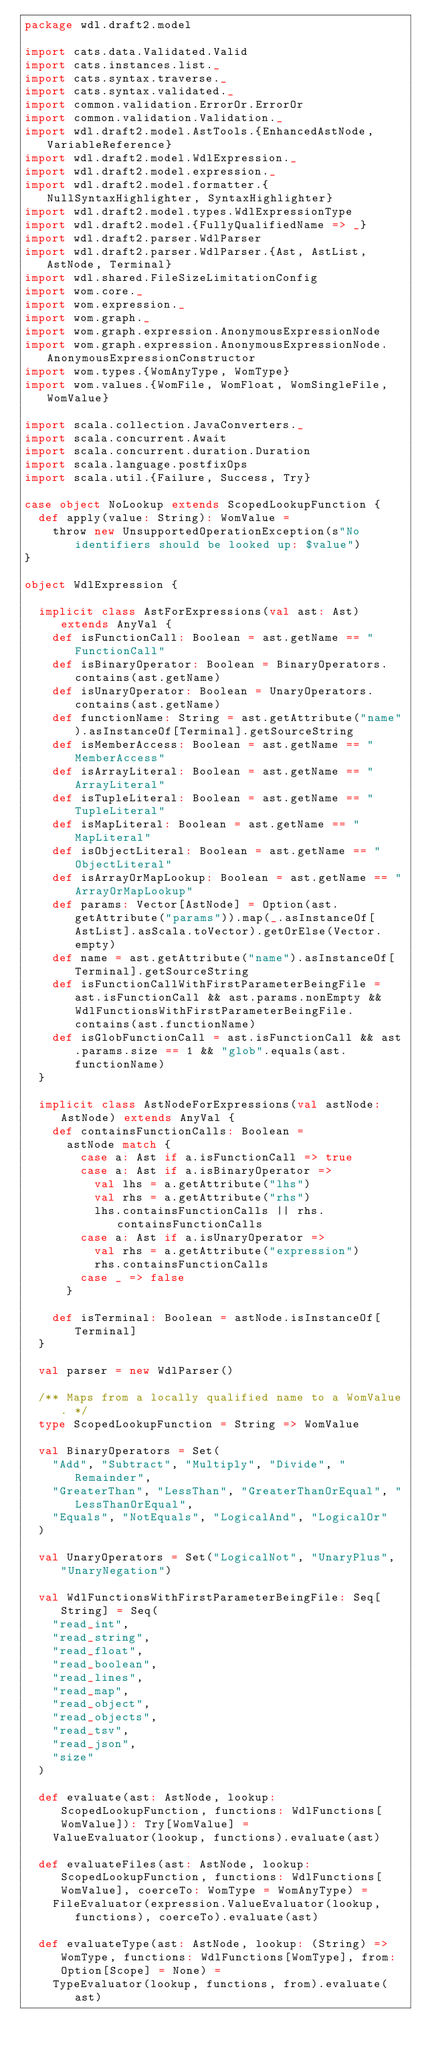<code> <loc_0><loc_0><loc_500><loc_500><_Scala_>package wdl.draft2.model

import cats.data.Validated.Valid
import cats.instances.list._
import cats.syntax.traverse._
import cats.syntax.validated._
import common.validation.ErrorOr.ErrorOr
import common.validation.Validation._
import wdl.draft2.model.AstTools.{EnhancedAstNode, VariableReference}
import wdl.draft2.model.WdlExpression._
import wdl.draft2.model.expression._
import wdl.draft2.model.formatter.{NullSyntaxHighlighter, SyntaxHighlighter}
import wdl.draft2.model.types.WdlExpressionType
import wdl.draft2.model.{FullyQualifiedName => _}
import wdl.draft2.parser.WdlParser
import wdl.draft2.parser.WdlParser.{Ast, AstList, AstNode, Terminal}
import wdl.shared.FileSizeLimitationConfig
import wom.core._
import wom.expression._
import wom.graph._
import wom.graph.expression.AnonymousExpressionNode
import wom.graph.expression.AnonymousExpressionNode.AnonymousExpressionConstructor
import wom.types.{WomAnyType, WomType}
import wom.values.{WomFile, WomFloat, WomSingleFile, WomValue}

import scala.collection.JavaConverters._
import scala.concurrent.Await
import scala.concurrent.duration.Duration
import scala.language.postfixOps
import scala.util.{Failure, Success, Try}

case object NoLookup extends ScopedLookupFunction {
  def apply(value: String): WomValue =
    throw new UnsupportedOperationException(s"No identifiers should be looked up: $value")
}

object WdlExpression {

  implicit class AstForExpressions(val ast: Ast) extends AnyVal {
    def isFunctionCall: Boolean = ast.getName == "FunctionCall"
    def isBinaryOperator: Boolean = BinaryOperators.contains(ast.getName)
    def isUnaryOperator: Boolean = UnaryOperators.contains(ast.getName)
    def functionName: String = ast.getAttribute("name").asInstanceOf[Terminal].getSourceString
    def isMemberAccess: Boolean = ast.getName == "MemberAccess"
    def isArrayLiteral: Boolean = ast.getName == "ArrayLiteral"
    def isTupleLiteral: Boolean = ast.getName == "TupleLiteral"
    def isMapLiteral: Boolean = ast.getName == "MapLiteral"
    def isObjectLiteral: Boolean = ast.getName == "ObjectLiteral"
    def isArrayOrMapLookup: Boolean = ast.getName == "ArrayOrMapLookup"
    def params: Vector[AstNode] = Option(ast.getAttribute("params")).map(_.asInstanceOf[AstList].asScala.toVector).getOrElse(Vector.empty)
    def name = ast.getAttribute("name").asInstanceOf[Terminal].getSourceString
    def isFunctionCallWithFirstParameterBeingFile = ast.isFunctionCall && ast.params.nonEmpty && WdlFunctionsWithFirstParameterBeingFile.contains(ast.functionName)
    def isGlobFunctionCall = ast.isFunctionCall && ast.params.size == 1 && "glob".equals(ast.functionName)
  }

  implicit class AstNodeForExpressions(val astNode: AstNode) extends AnyVal {
    def containsFunctionCalls: Boolean =
      astNode match {
        case a: Ast if a.isFunctionCall => true
        case a: Ast if a.isBinaryOperator =>
          val lhs = a.getAttribute("lhs")
          val rhs = a.getAttribute("rhs")
          lhs.containsFunctionCalls || rhs.containsFunctionCalls
        case a: Ast if a.isUnaryOperator =>
          val rhs = a.getAttribute("expression")
          rhs.containsFunctionCalls
        case _ => false
      }

    def isTerminal: Boolean = astNode.isInstanceOf[Terminal]
  }

  val parser = new WdlParser()

  /** Maps from a locally qualified name to a WomValue. */
  type ScopedLookupFunction = String => WomValue

  val BinaryOperators = Set(
    "Add", "Subtract", "Multiply", "Divide", "Remainder",
    "GreaterThan", "LessThan", "GreaterThanOrEqual", "LessThanOrEqual",
    "Equals", "NotEquals", "LogicalAnd", "LogicalOr"
  )

  val UnaryOperators = Set("LogicalNot", "UnaryPlus", "UnaryNegation")

  val WdlFunctionsWithFirstParameterBeingFile: Seq[String] = Seq(
    "read_int",
    "read_string",
    "read_float",
    "read_boolean",
    "read_lines",
    "read_map",
    "read_object",
    "read_objects",
    "read_tsv",
    "read_json",
    "size"
  )

  def evaluate(ast: AstNode, lookup: ScopedLookupFunction, functions: WdlFunctions[WomValue]): Try[WomValue] =
    ValueEvaluator(lookup, functions).evaluate(ast)

  def evaluateFiles(ast: AstNode, lookup: ScopedLookupFunction, functions: WdlFunctions[WomValue], coerceTo: WomType = WomAnyType) =
    FileEvaluator(expression.ValueEvaluator(lookup, functions), coerceTo).evaluate(ast)

  def evaluateType(ast: AstNode, lookup: (String) => WomType, functions: WdlFunctions[WomType], from: Option[Scope] = None) =
    TypeEvaluator(lookup, functions, from).evaluate(ast)
</code> 